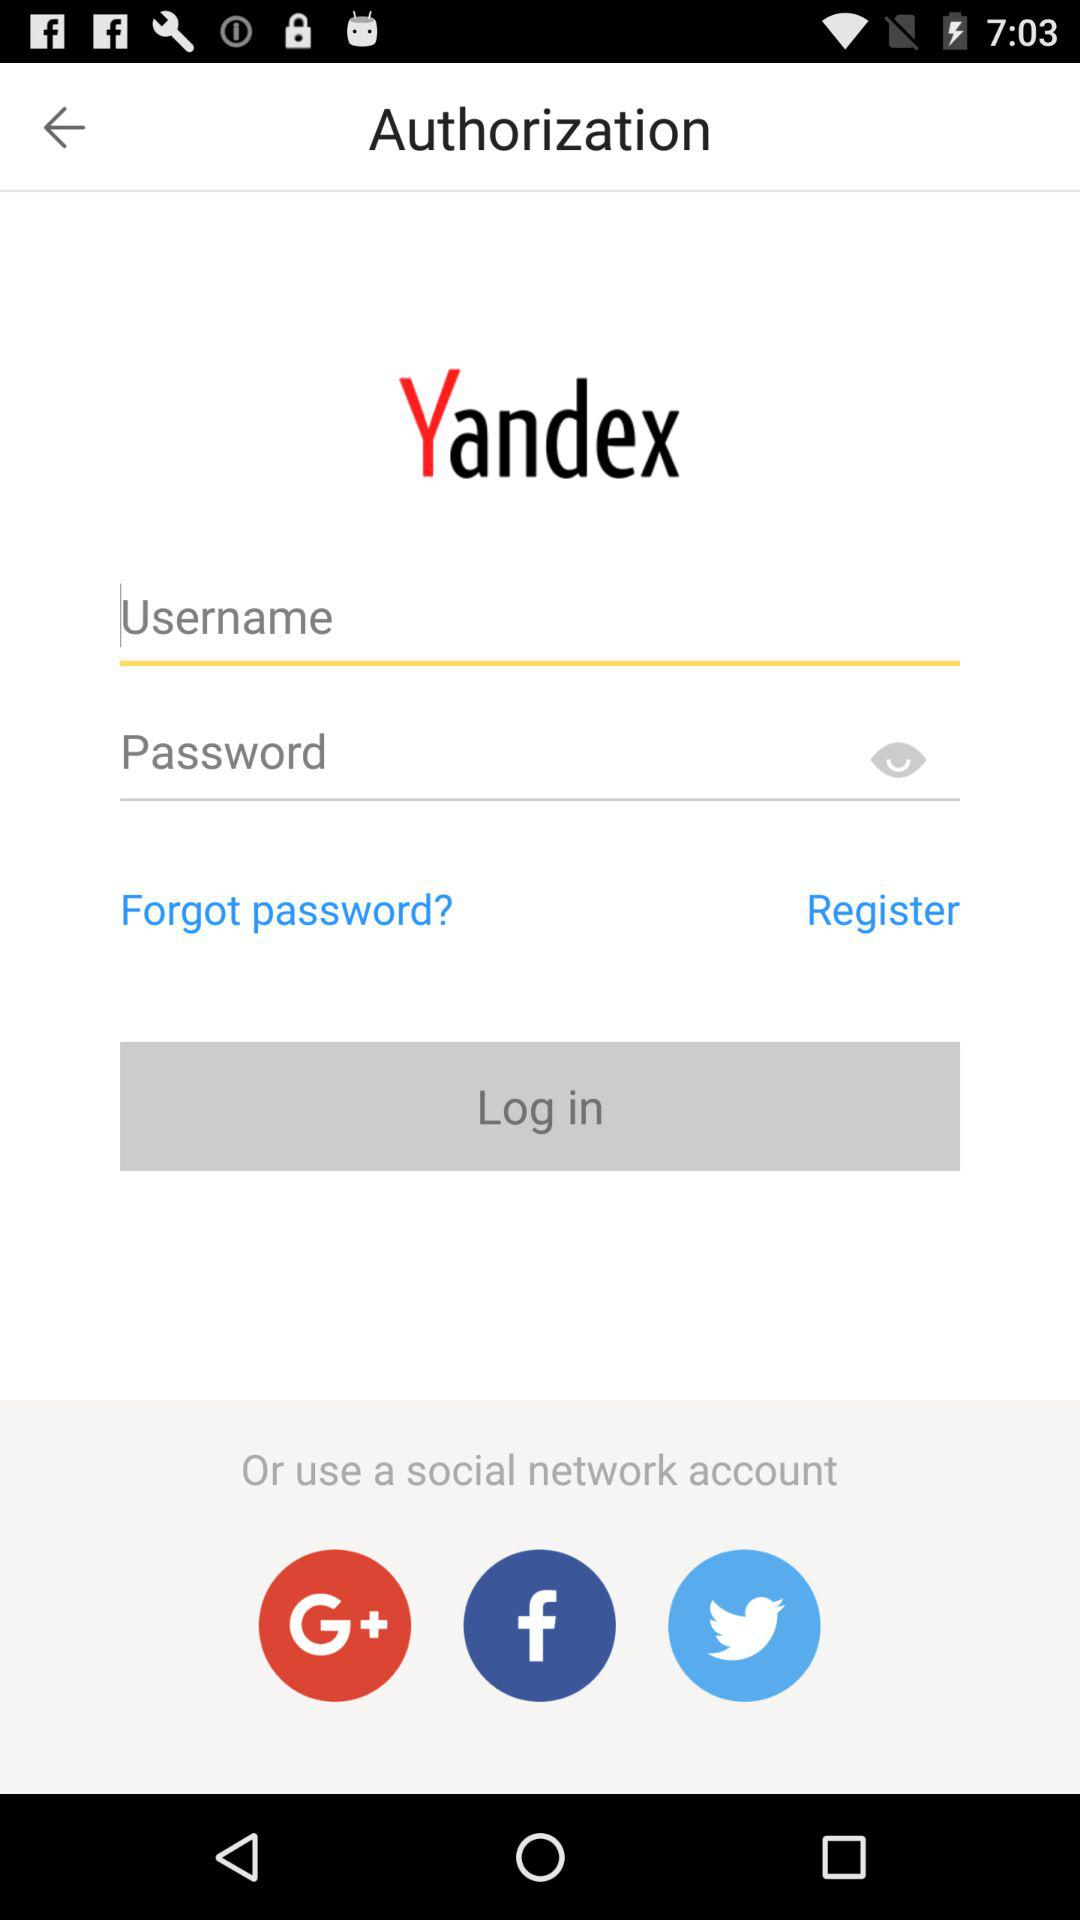How many social network login options are there?
Answer the question using a single word or phrase. 3 